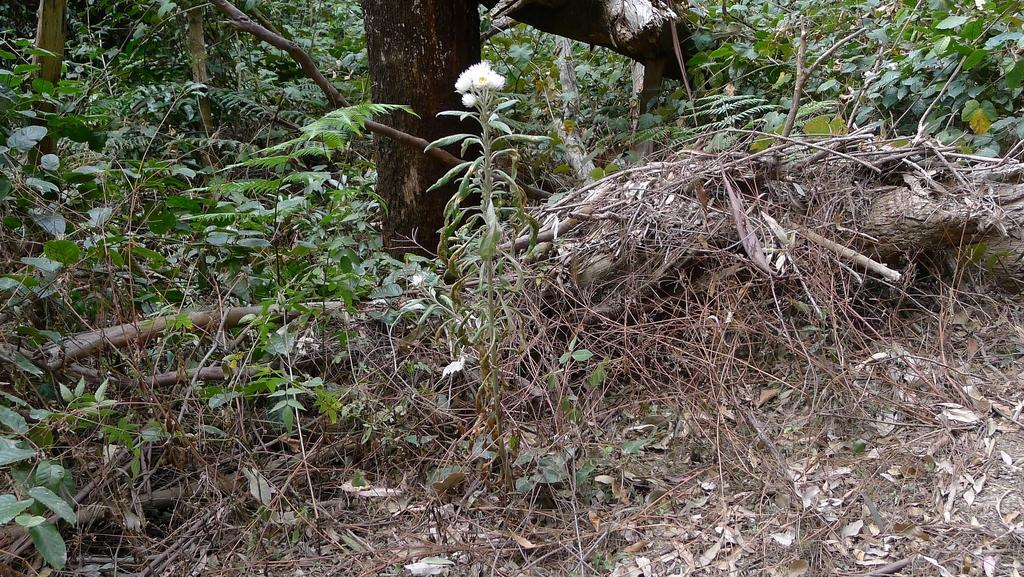What type of living organisms can be seen in the image? Plants and flowers are visible in the image. Can you describe the specific plants or flowers in the image? Unfortunately, the facts provided do not give specific details about the plants or flowers in the image. What is the natural setting visible in the image? The presence of plants and flowers suggests a natural setting, but the specific location or environment cannot be determined from the facts provided. What type of bait is being used to catch fish in the image? There is no mention of fish or bait in the image, as it only contains plants and flowers. 